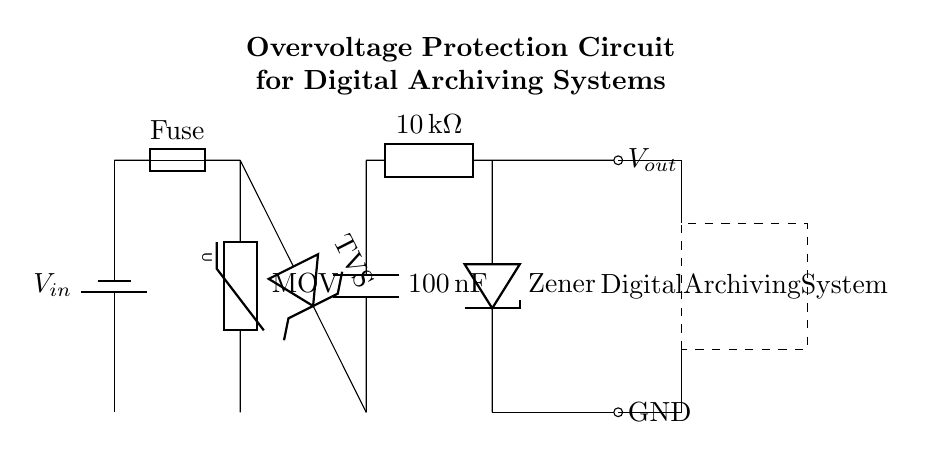What type of battery is used in this circuit? The circuit diagram indicates a 'battery1', which refers to a generic battery symbol. There is no specific voltage or type mentioned in the diagram, but it is recognized as a standard power supply.
Answer: battery What is the function of the MOV in the circuit? The MOV, or Metal Oxide Varistor, is designed to clamp excessive voltage transients, protecting downstream components from overvoltage. Its placement in parallel with the load allows it to absorb spikes and prevent damage.
Answer: Overvoltage protection What is the capacitance value of the capacitor in the circuit? The capacitor is labeled with a value of '100 nanoFarads'. This indicates its ability to store electrical energy and helps filter out noise in the power supply.
Answer: 100 nanoFarads What would happen if the fuse were to blow? If the fuse blows, it will break the circuit, cutting off power supply to the entire system and preventing any current flow to downstream components, effectively protecting them from damage.
Answer: Circuit protection How many major protective components are present in the circuit? The circuit contains several protective components: a fuse, a varistor, a TVS diode, and a Zener diode. All these components work together to ensure the safety of the digital archiving system from voltage spikes.
Answer: Four What is the purpose of the Zener diode in the circuit? The Zener diode allows current to flow in the reverse direction when the voltage exceeds a certain level, helping to regulate and limit voltage, thus preventing damage to the load by ensuring that voltage does not exceed safe levels.
Answer: Voltage regulation Where is the output voltage measured in relation to the circuit? The output voltage, labeled as 'Vout', is measured at the terminal of the Zener diode, specifically at the junction leading to the digital archiving system.
Answer: At the Zener diode 